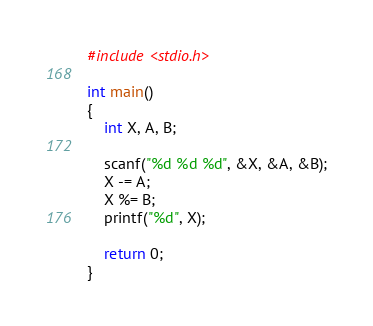Convert code to text. <code><loc_0><loc_0><loc_500><loc_500><_C_>#include <stdio.h>

int main()
{
	int X, A, B;

	scanf("%d %d %d", &X, &A, &B);
	X -= A;
	X %= B;
	printf("%d", X);
	
	return 0;
}
</code> 